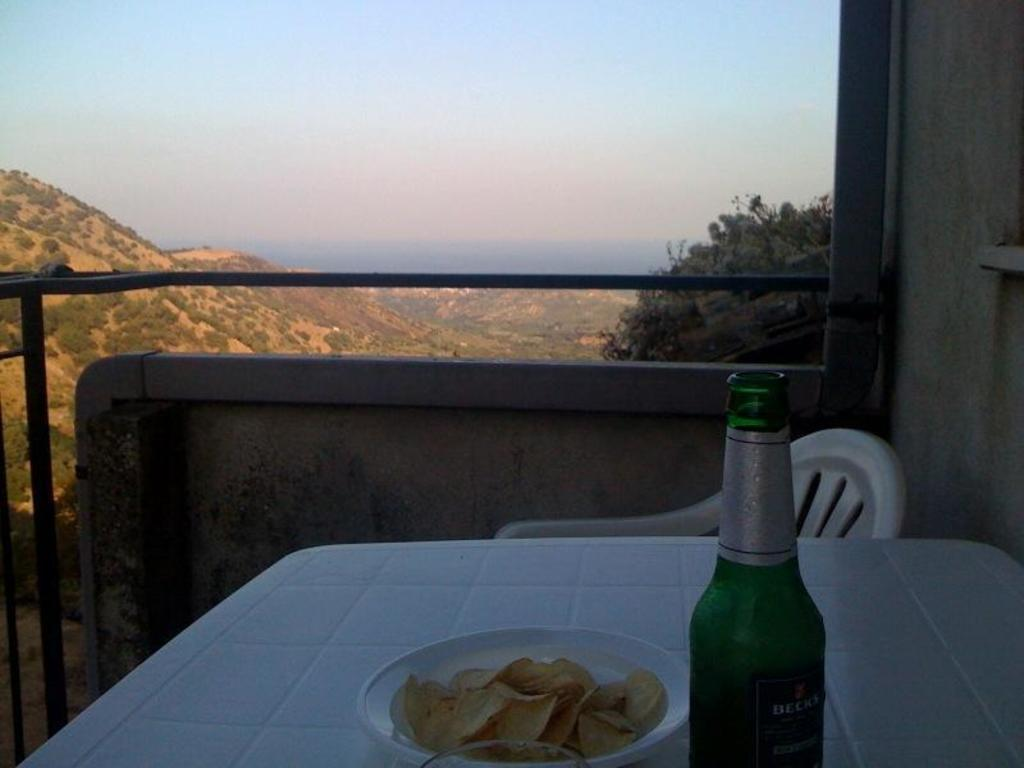What piece of furniture is present in the image? There is a table in the image. What is on the table? There is a plate on the table, and it contains chips. What type of beverage container is in the image? There is a bottle in the image. What type of seating is available in the image? There is a chair in the image. What type of vegetation is visible in the image? There is a tree in the image. What can be seen in the background of the image? The sky is visible in the background, and there are small plants in the background. What type of protest is taking place in the image? There is no protest present in the image. What religious symbols can be seen in the image? There are no religious symbols present in the image. How many geese are visible in the image? There are no geese present in the image. 